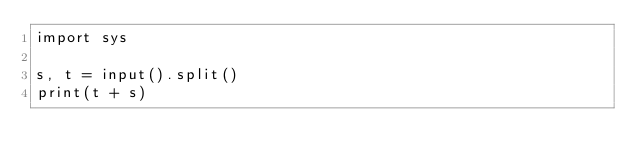Convert code to text. <code><loc_0><loc_0><loc_500><loc_500><_Python_>import sys

s, t = input().split()
print(t + s)</code> 